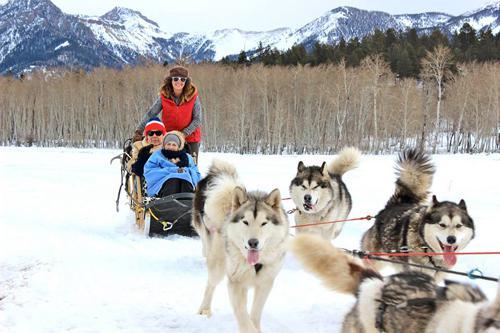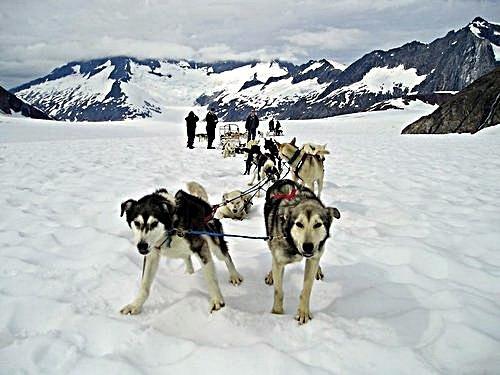The first image is the image on the left, the second image is the image on the right. For the images displayed, is the sentence "In at least one image there is a person in blue in the sled and a person in red behind the sled." factually correct? Answer yes or no. Yes. 